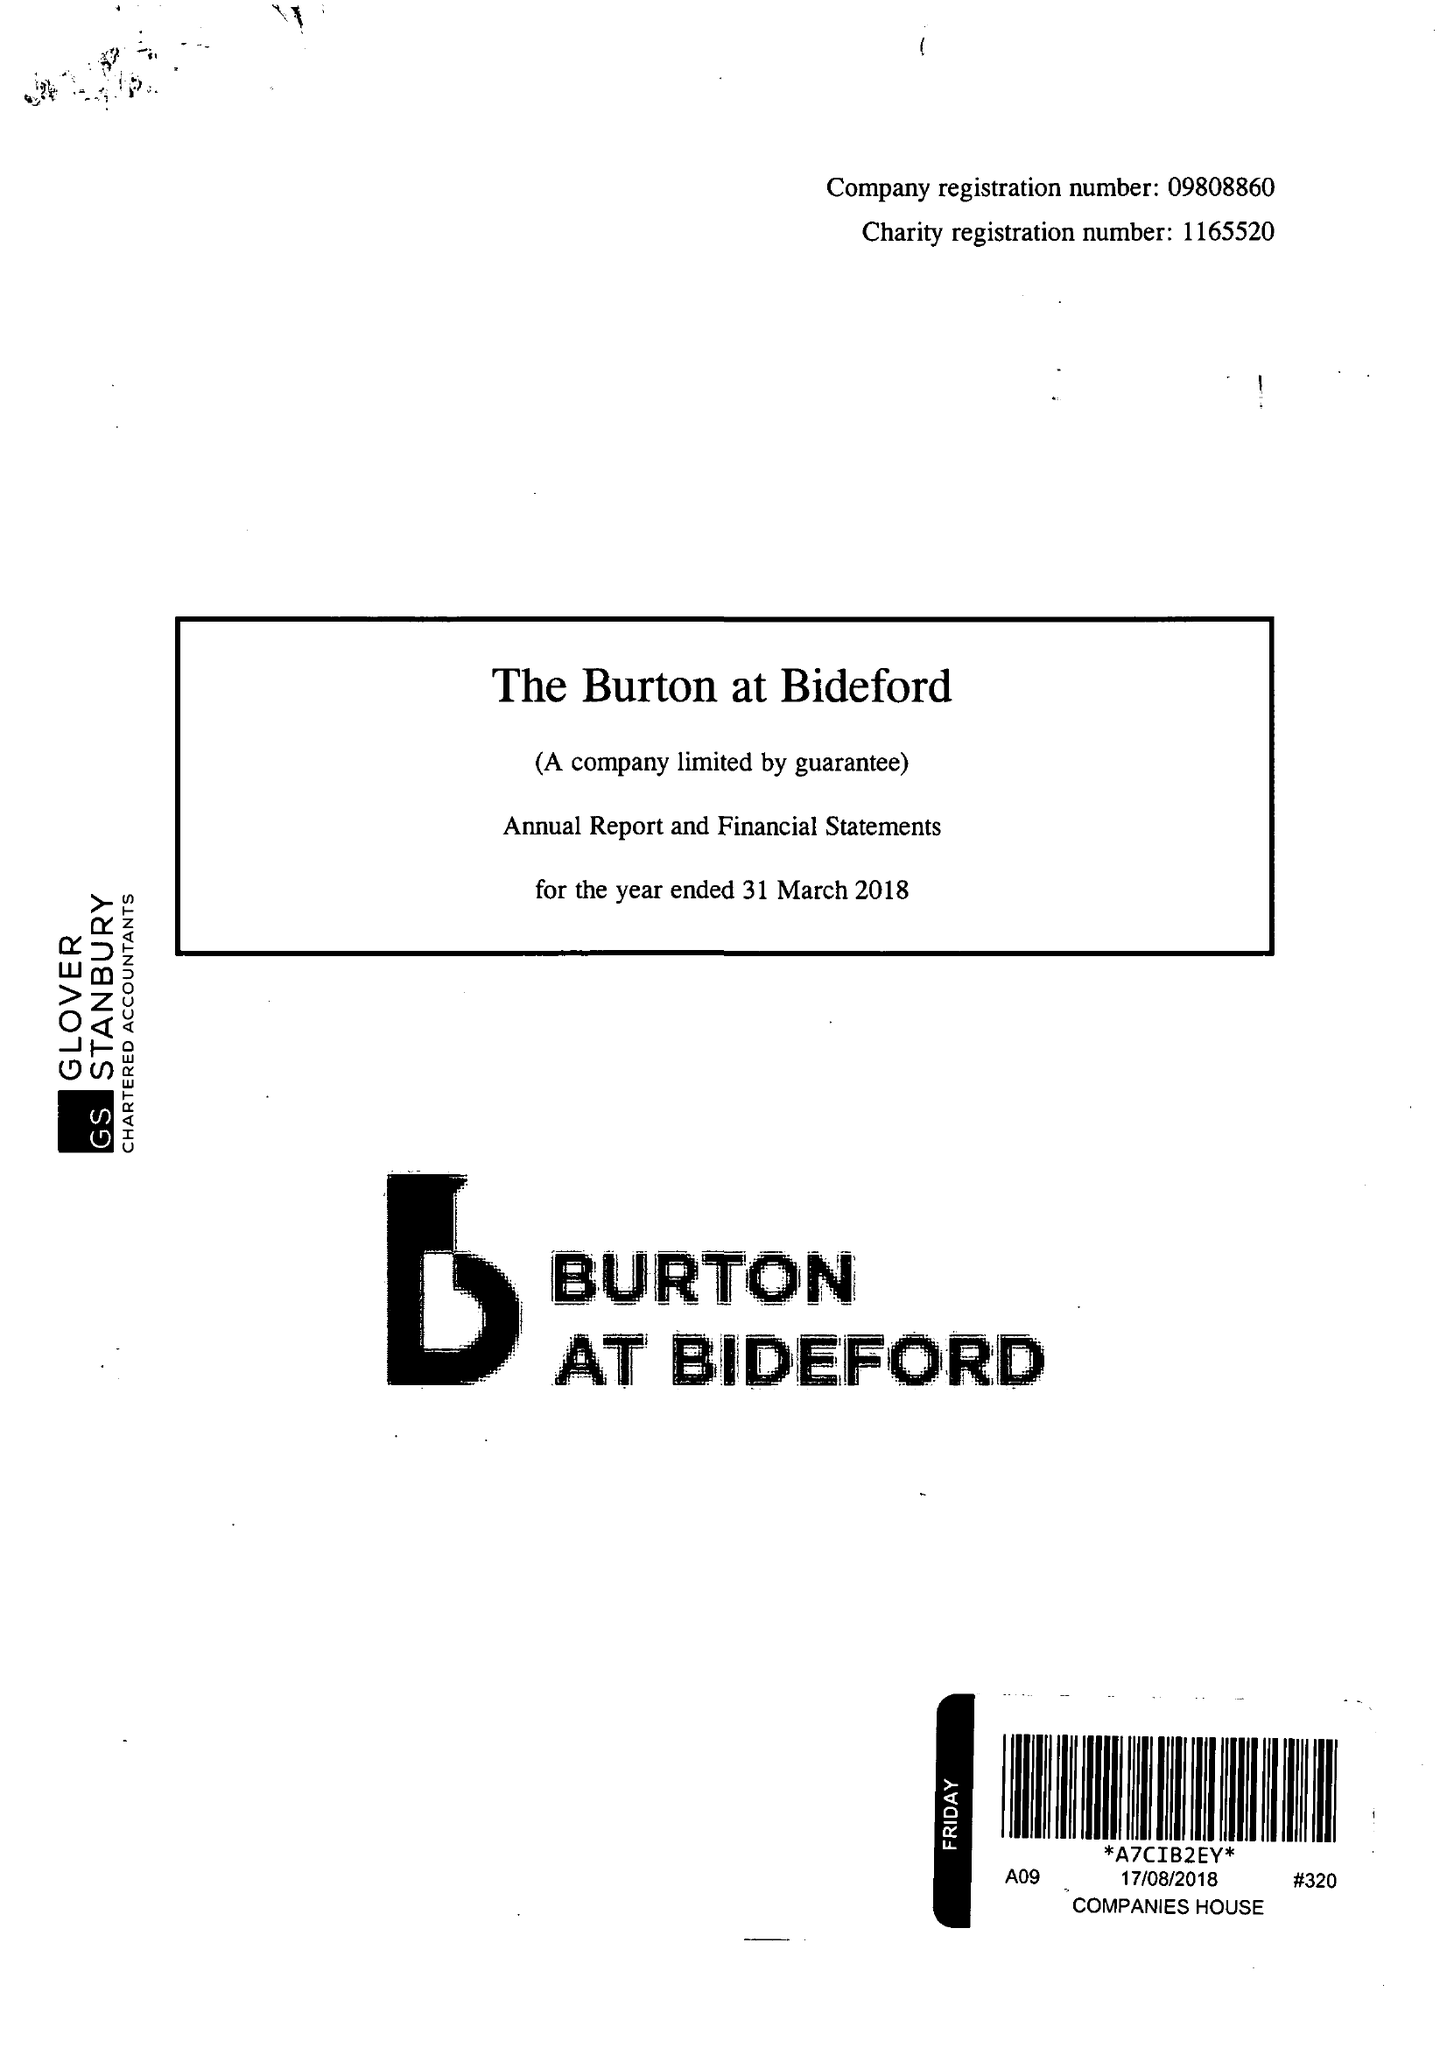What is the value for the income_annually_in_british_pounds?
Answer the question using a single word or phrase. 296463.00 